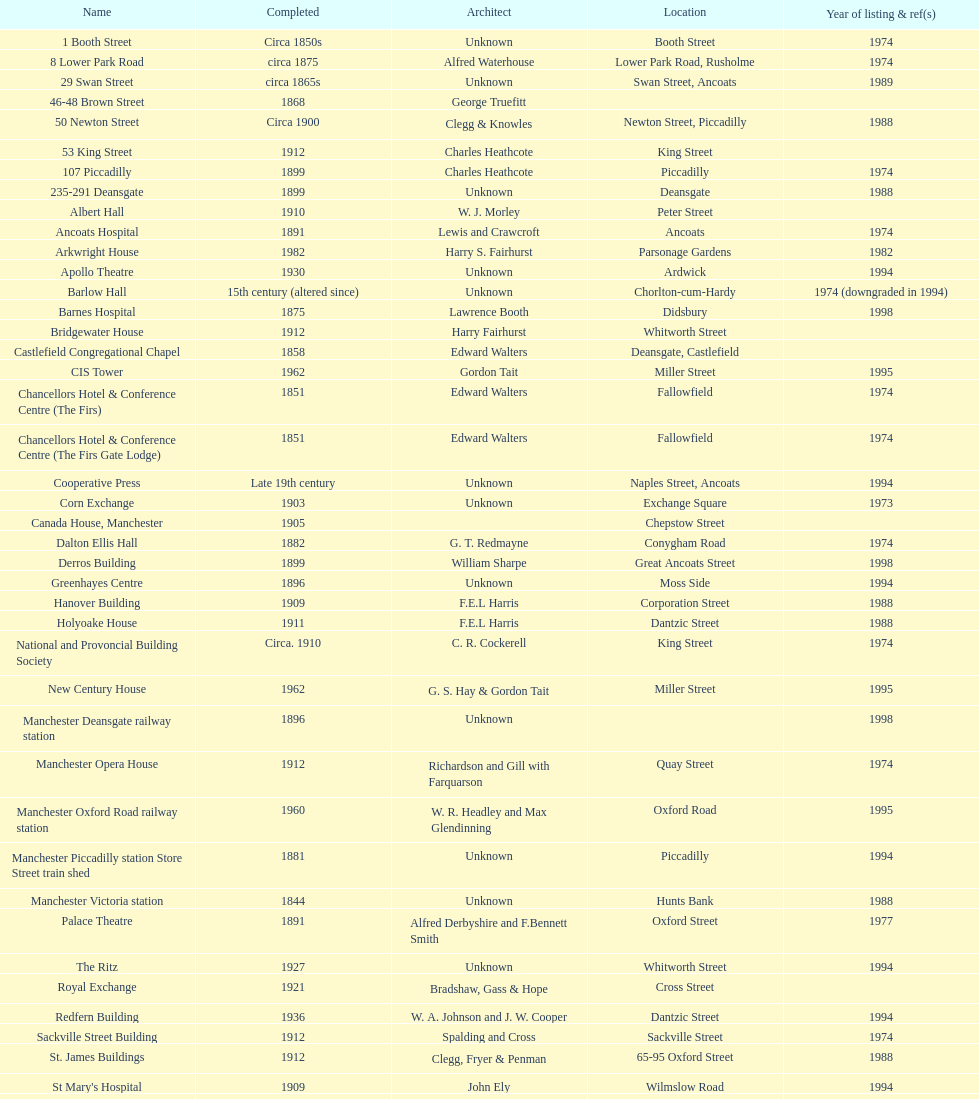Was charles heathcote the architect of ancoats hospital and apollo theatre? No. 